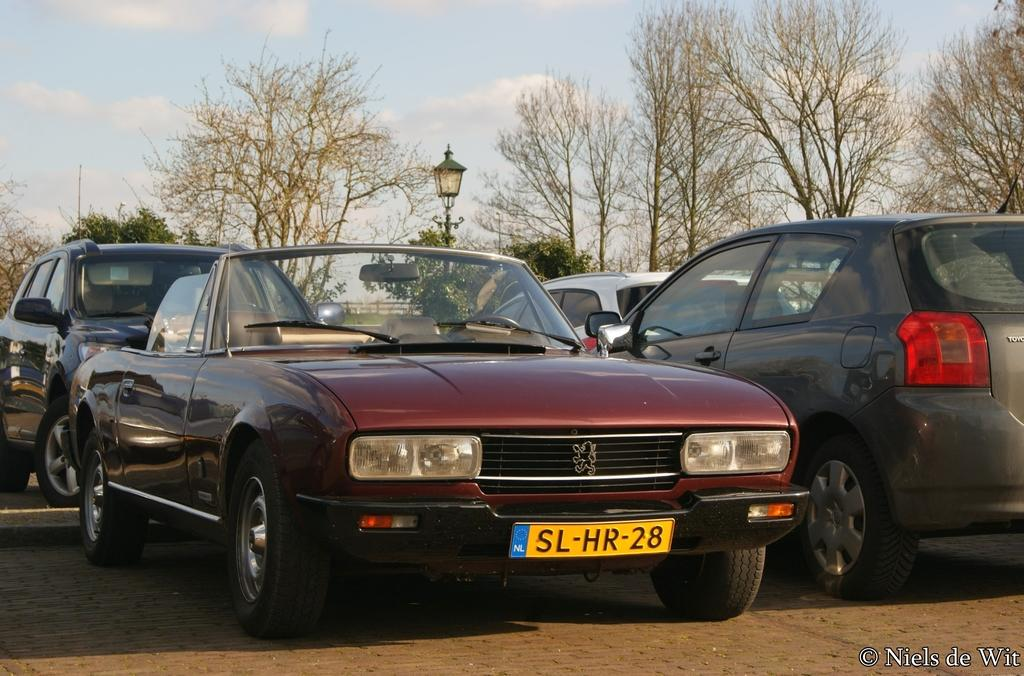What can be seen parked in the image? There are cars parked in the image. What type of light is present in the image? There is a pole light in the image. What type of vegetation is visible in the image? There are trees visible in the image. How would you describe the sky in the image? The sky is blue and cloudy in the image. Where is the text located in the image? The text is at the bottom right corner of the image. Are there any cherries hanging from the trees in the image? There is no mention of cherries in the image; only trees are mentioned. Can you see a net used for sports in the image? There is no net visible in the image. 